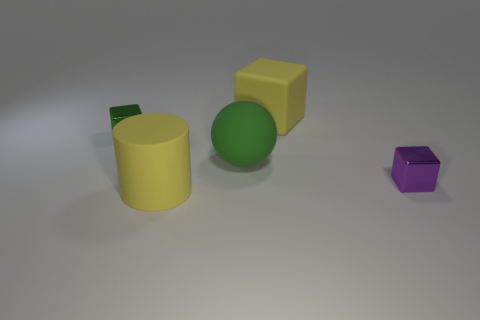Subtract all big rubber blocks. How many blocks are left? 2 Subtract all purple blocks. How many blocks are left? 2 Add 1 big green matte things. How many objects exist? 6 Subtract all spheres. How many objects are left? 4 Subtract all green cylinders. How many yellow blocks are left? 1 Subtract all purple metallic cubes. Subtract all small purple blocks. How many objects are left? 3 Add 4 matte balls. How many matte balls are left? 5 Add 1 green objects. How many green objects exist? 3 Subtract 1 green balls. How many objects are left? 4 Subtract 2 cubes. How many cubes are left? 1 